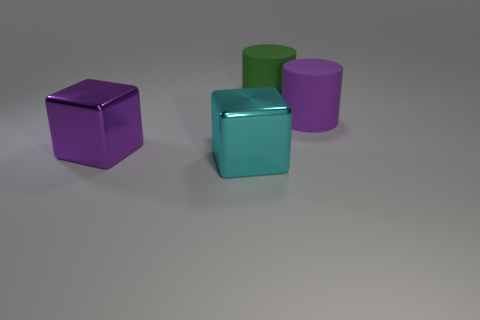Is the number of cyan metal blocks behind the big cyan cube greater than the number of purple matte cubes? No, there are no cyan metal blocks behind the big cyan cube. In the image, we can see only one sizable cyan cube in the foreground, and there is a single purple matte cube as well. Since there are no additional cyan blocks behind the big cube, it's not possible for their number to be greater than that of the purple cubes. 